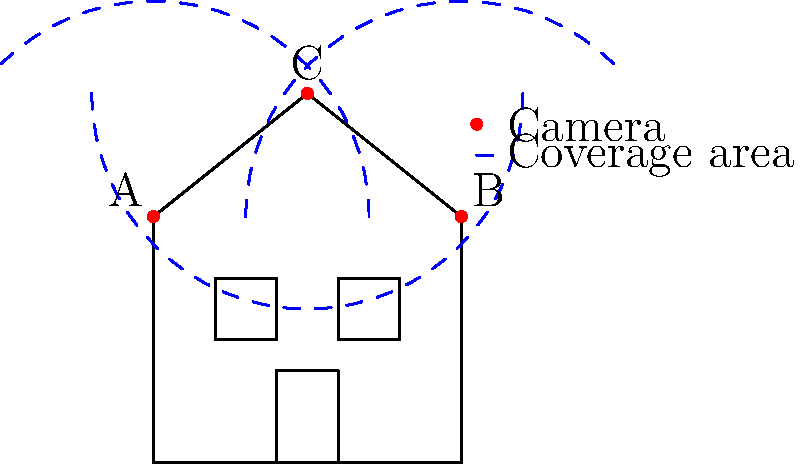As a smart home consultant, you're tasked with optimizing the security camera setup for a client's house. Given the diagram showing three potential camera locations (A, B, and C) and their coverage areas, which combination of two cameras provides the best overall coverage of the property? To determine the best combination of two cameras for maximum coverage, let's analyze each possible pair:

1. Cameras A and B:
   - Cover the front of the house and sides
   - Leave a significant blind spot at the back and top of the house

2. Cameras A and C:
   - Cover the left side, front, and top of the house
   - Leave a blind spot on the right side

3. Cameras B and C:
   - Cover the right side, front, and top of the house
   - Leave a blind spot on the left side

Step 1: Eliminate the weakest option
Cameras A and B together leave the largest blind spot, so we can eliminate this combination.

Step 2: Compare remaining options
Both A+C and B+C provide good coverage of the front and top of the house. The decision comes down to whether it's more important to cover the left side (A+C) or the right side (B+C).

Step 3: Consider potential vulnerabilities
In most cases, the right side of the house (where camera B is located) is more vulnerable because it's further from the street and potentially more hidden from neighbors. This makes it a more likely entry point for intruders.

Step 4: Make the final decision
Based on the analysis, the combination of cameras B and C provides the best overall coverage. It protects the most vulnerable areas (right side and back) while still maintaining visibility of the front and top of the house.
Answer: Cameras B and C 